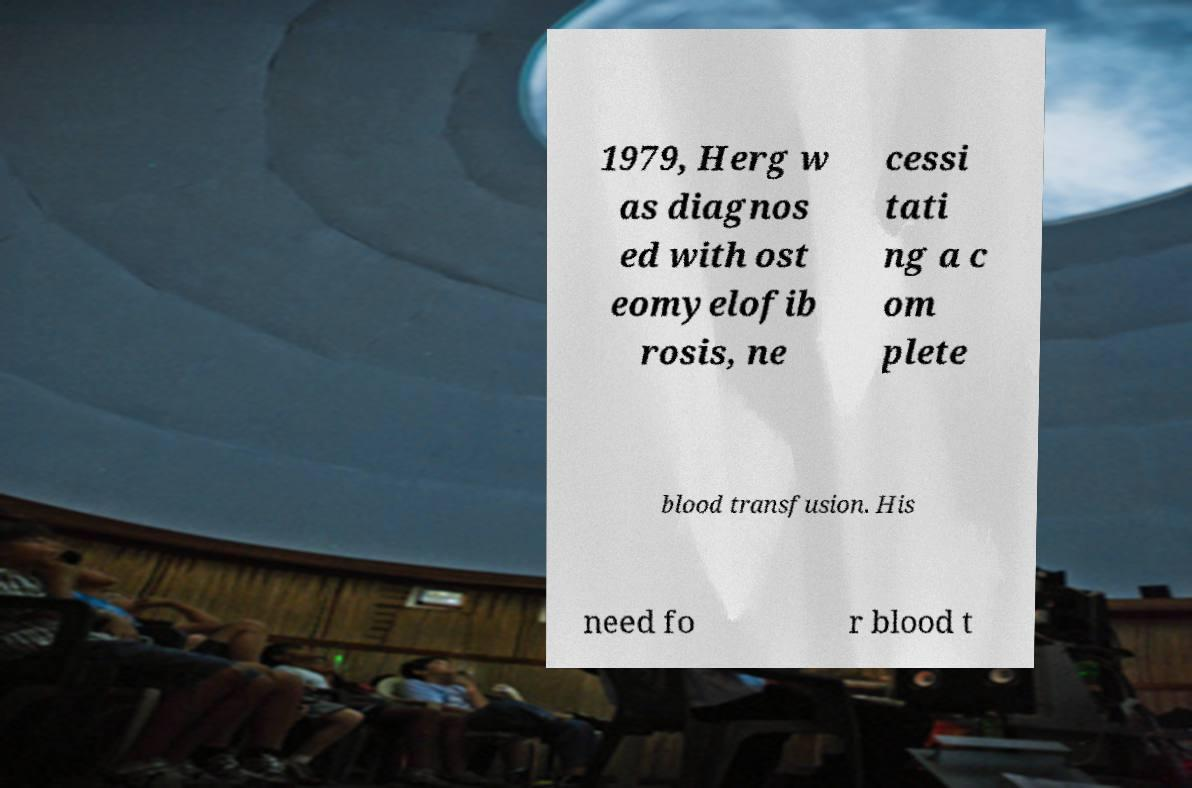There's text embedded in this image that I need extracted. Can you transcribe it verbatim? 1979, Herg w as diagnos ed with ost eomyelofib rosis, ne cessi tati ng a c om plete blood transfusion. His need fo r blood t 